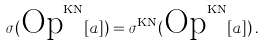Convert formula to latex. <formula><loc_0><loc_0><loc_500><loc_500>\sigma ( \text {Op} ^ { \text {KN} } [ a ] ) = \sigma ^ { \text {KN} } ( \text {Op} ^ { \text {KN} } [ a ] ) \, .</formula> 